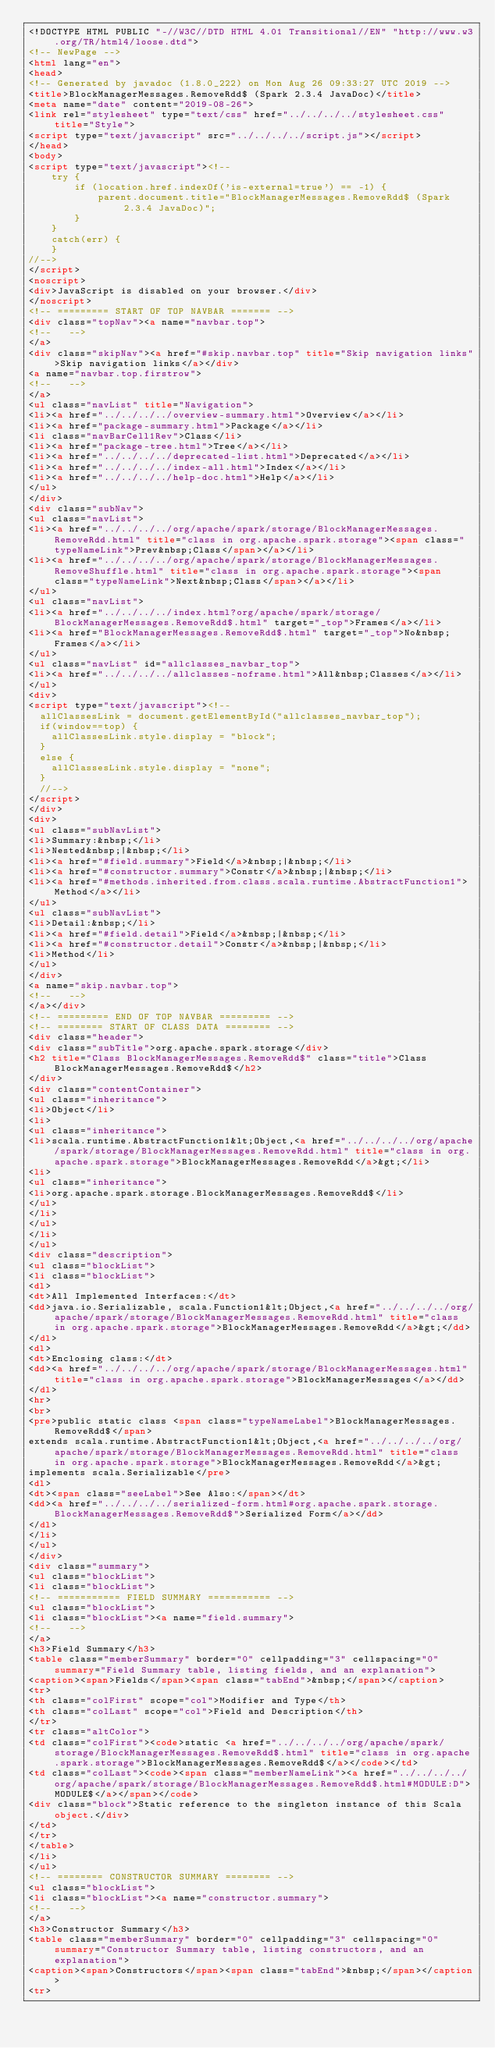Convert code to text. <code><loc_0><loc_0><loc_500><loc_500><_HTML_><!DOCTYPE HTML PUBLIC "-//W3C//DTD HTML 4.01 Transitional//EN" "http://www.w3.org/TR/html4/loose.dtd">
<!-- NewPage -->
<html lang="en">
<head>
<!-- Generated by javadoc (1.8.0_222) on Mon Aug 26 09:33:27 UTC 2019 -->
<title>BlockManagerMessages.RemoveRdd$ (Spark 2.3.4 JavaDoc)</title>
<meta name="date" content="2019-08-26">
<link rel="stylesheet" type="text/css" href="../../../../stylesheet.css" title="Style">
<script type="text/javascript" src="../../../../script.js"></script>
</head>
<body>
<script type="text/javascript"><!--
    try {
        if (location.href.indexOf('is-external=true') == -1) {
            parent.document.title="BlockManagerMessages.RemoveRdd$ (Spark 2.3.4 JavaDoc)";
        }
    }
    catch(err) {
    }
//-->
</script>
<noscript>
<div>JavaScript is disabled on your browser.</div>
</noscript>
<!-- ========= START OF TOP NAVBAR ======= -->
<div class="topNav"><a name="navbar.top">
<!--   -->
</a>
<div class="skipNav"><a href="#skip.navbar.top" title="Skip navigation links">Skip navigation links</a></div>
<a name="navbar.top.firstrow">
<!--   -->
</a>
<ul class="navList" title="Navigation">
<li><a href="../../../../overview-summary.html">Overview</a></li>
<li><a href="package-summary.html">Package</a></li>
<li class="navBarCell1Rev">Class</li>
<li><a href="package-tree.html">Tree</a></li>
<li><a href="../../../../deprecated-list.html">Deprecated</a></li>
<li><a href="../../../../index-all.html">Index</a></li>
<li><a href="../../../../help-doc.html">Help</a></li>
</ul>
</div>
<div class="subNav">
<ul class="navList">
<li><a href="../../../../org/apache/spark/storage/BlockManagerMessages.RemoveRdd.html" title="class in org.apache.spark.storage"><span class="typeNameLink">Prev&nbsp;Class</span></a></li>
<li><a href="../../../../org/apache/spark/storage/BlockManagerMessages.RemoveShuffle.html" title="class in org.apache.spark.storage"><span class="typeNameLink">Next&nbsp;Class</span></a></li>
</ul>
<ul class="navList">
<li><a href="../../../../index.html?org/apache/spark/storage/BlockManagerMessages.RemoveRdd$.html" target="_top">Frames</a></li>
<li><a href="BlockManagerMessages.RemoveRdd$.html" target="_top">No&nbsp;Frames</a></li>
</ul>
<ul class="navList" id="allclasses_navbar_top">
<li><a href="../../../../allclasses-noframe.html">All&nbsp;Classes</a></li>
</ul>
<div>
<script type="text/javascript"><!--
  allClassesLink = document.getElementById("allclasses_navbar_top");
  if(window==top) {
    allClassesLink.style.display = "block";
  }
  else {
    allClassesLink.style.display = "none";
  }
  //-->
</script>
</div>
<div>
<ul class="subNavList">
<li>Summary:&nbsp;</li>
<li>Nested&nbsp;|&nbsp;</li>
<li><a href="#field.summary">Field</a>&nbsp;|&nbsp;</li>
<li><a href="#constructor.summary">Constr</a>&nbsp;|&nbsp;</li>
<li><a href="#methods.inherited.from.class.scala.runtime.AbstractFunction1">Method</a></li>
</ul>
<ul class="subNavList">
<li>Detail:&nbsp;</li>
<li><a href="#field.detail">Field</a>&nbsp;|&nbsp;</li>
<li><a href="#constructor.detail">Constr</a>&nbsp;|&nbsp;</li>
<li>Method</li>
</ul>
</div>
<a name="skip.navbar.top">
<!--   -->
</a></div>
<!-- ========= END OF TOP NAVBAR ========= -->
<!-- ======== START OF CLASS DATA ======== -->
<div class="header">
<div class="subTitle">org.apache.spark.storage</div>
<h2 title="Class BlockManagerMessages.RemoveRdd$" class="title">Class BlockManagerMessages.RemoveRdd$</h2>
</div>
<div class="contentContainer">
<ul class="inheritance">
<li>Object</li>
<li>
<ul class="inheritance">
<li>scala.runtime.AbstractFunction1&lt;Object,<a href="../../../../org/apache/spark/storage/BlockManagerMessages.RemoveRdd.html" title="class in org.apache.spark.storage">BlockManagerMessages.RemoveRdd</a>&gt;</li>
<li>
<ul class="inheritance">
<li>org.apache.spark.storage.BlockManagerMessages.RemoveRdd$</li>
</ul>
</li>
</ul>
</li>
</ul>
<div class="description">
<ul class="blockList">
<li class="blockList">
<dl>
<dt>All Implemented Interfaces:</dt>
<dd>java.io.Serializable, scala.Function1&lt;Object,<a href="../../../../org/apache/spark/storage/BlockManagerMessages.RemoveRdd.html" title="class in org.apache.spark.storage">BlockManagerMessages.RemoveRdd</a>&gt;</dd>
</dl>
<dl>
<dt>Enclosing class:</dt>
<dd><a href="../../../../org/apache/spark/storage/BlockManagerMessages.html" title="class in org.apache.spark.storage">BlockManagerMessages</a></dd>
</dl>
<hr>
<br>
<pre>public static class <span class="typeNameLabel">BlockManagerMessages.RemoveRdd$</span>
extends scala.runtime.AbstractFunction1&lt;Object,<a href="../../../../org/apache/spark/storage/BlockManagerMessages.RemoveRdd.html" title="class in org.apache.spark.storage">BlockManagerMessages.RemoveRdd</a>&gt;
implements scala.Serializable</pre>
<dl>
<dt><span class="seeLabel">See Also:</span></dt>
<dd><a href="../../../../serialized-form.html#org.apache.spark.storage.BlockManagerMessages.RemoveRdd$">Serialized Form</a></dd>
</dl>
</li>
</ul>
</div>
<div class="summary">
<ul class="blockList">
<li class="blockList">
<!-- =========== FIELD SUMMARY =========== -->
<ul class="blockList">
<li class="blockList"><a name="field.summary">
<!--   -->
</a>
<h3>Field Summary</h3>
<table class="memberSummary" border="0" cellpadding="3" cellspacing="0" summary="Field Summary table, listing fields, and an explanation">
<caption><span>Fields</span><span class="tabEnd">&nbsp;</span></caption>
<tr>
<th class="colFirst" scope="col">Modifier and Type</th>
<th class="colLast" scope="col">Field and Description</th>
</tr>
<tr class="altColor">
<td class="colFirst"><code>static <a href="../../../../org/apache/spark/storage/BlockManagerMessages.RemoveRdd$.html" title="class in org.apache.spark.storage">BlockManagerMessages.RemoveRdd$</a></code></td>
<td class="colLast"><code><span class="memberNameLink"><a href="../../../../org/apache/spark/storage/BlockManagerMessages.RemoveRdd$.html#MODULE:D">MODULE$</a></span></code>
<div class="block">Static reference to the singleton instance of this Scala object.</div>
</td>
</tr>
</table>
</li>
</ul>
<!-- ======== CONSTRUCTOR SUMMARY ======== -->
<ul class="blockList">
<li class="blockList"><a name="constructor.summary">
<!--   -->
</a>
<h3>Constructor Summary</h3>
<table class="memberSummary" border="0" cellpadding="3" cellspacing="0" summary="Constructor Summary table, listing constructors, and an explanation">
<caption><span>Constructors</span><span class="tabEnd">&nbsp;</span></caption>
<tr></code> 